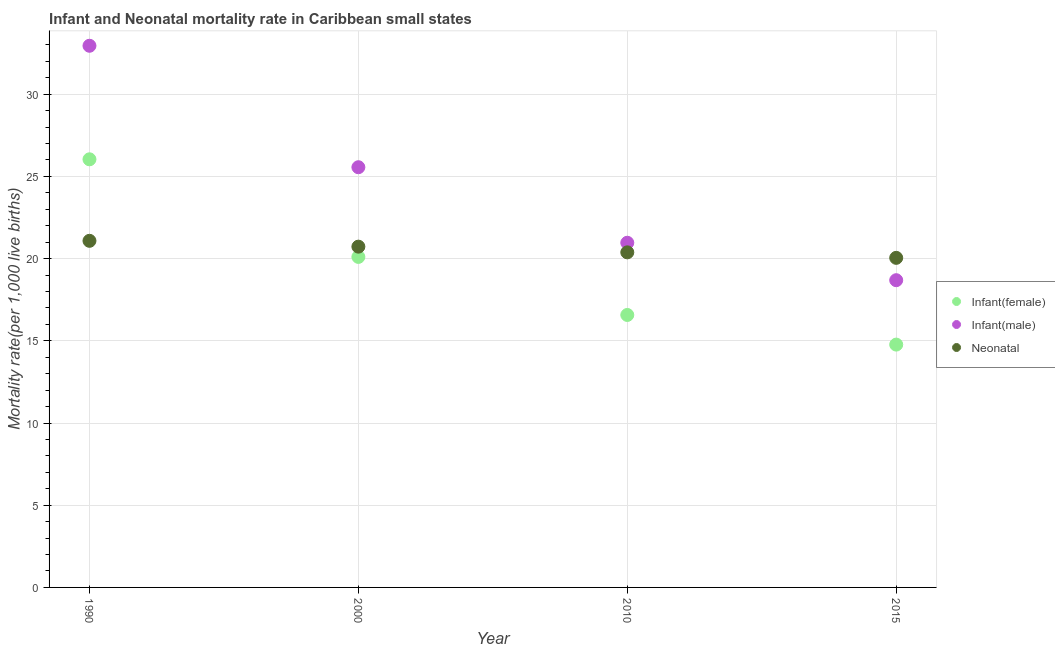How many different coloured dotlines are there?
Provide a short and direct response. 3. What is the neonatal mortality rate in 1990?
Offer a very short reply. 21.08. Across all years, what is the maximum infant mortality rate(female)?
Your answer should be compact. 26.04. Across all years, what is the minimum infant mortality rate(male)?
Give a very brief answer. 18.69. In which year was the infant mortality rate(male) minimum?
Offer a very short reply. 2015. What is the total infant mortality rate(male) in the graph?
Your answer should be very brief. 98.15. What is the difference between the infant mortality rate(female) in 2000 and that in 2015?
Ensure brevity in your answer.  5.33. What is the difference between the infant mortality rate(male) in 2000 and the neonatal mortality rate in 2015?
Make the answer very short. 5.51. What is the average infant mortality rate(male) per year?
Provide a short and direct response. 24.54. In the year 2000, what is the difference between the infant mortality rate(male) and infant mortality rate(female)?
Provide a short and direct response. 5.46. What is the ratio of the infant mortality rate(male) in 1990 to that in 2010?
Your answer should be very brief. 1.57. Is the difference between the infant mortality rate(female) in 2000 and 2015 greater than the difference between the infant mortality rate(male) in 2000 and 2015?
Make the answer very short. No. What is the difference between the highest and the second highest neonatal mortality rate?
Make the answer very short. 0.35. What is the difference between the highest and the lowest neonatal mortality rate?
Provide a short and direct response. 1.04. In how many years, is the infant mortality rate(male) greater than the average infant mortality rate(male) taken over all years?
Keep it short and to the point. 2. Is the sum of the neonatal mortality rate in 1990 and 2015 greater than the maximum infant mortality rate(male) across all years?
Provide a short and direct response. Yes. Is it the case that in every year, the sum of the infant mortality rate(female) and infant mortality rate(male) is greater than the neonatal mortality rate?
Provide a succinct answer. Yes. How many dotlines are there?
Make the answer very short. 3. Does the graph contain any zero values?
Provide a succinct answer. No. Where does the legend appear in the graph?
Offer a very short reply. Center right. How many legend labels are there?
Your answer should be compact. 3. What is the title of the graph?
Offer a very short reply. Infant and Neonatal mortality rate in Caribbean small states. Does "Taxes on international trade" appear as one of the legend labels in the graph?
Provide a succinct answer. No. What is the label or title of the Y-axis?
Provide a short and direct response. Mortality rate(per 1,0 live births). What is the Mortality rate(per 1,000 live births) in Infant(female) in 1990?
Keep it short and to the point. 26.04. What is the Mortality rate(per 1,000 live births) in Infant(male) in 1990?
Keep it short and to the point. 32.95. What is the Mortality rate(per 1,000 live births) of Neonatal  in 1990?
Your answer should be very brief. 21.08. What is the Mortality rate(per 1,000 live births) in Infant(female) in 2000?
Offer a very short reply. 20.1. What is the Mortality rate(per 1,000 live births) of Infant(male) in 2000?
Give a very brief answer. 25.56. What is the Mortality rate(per 1,000 live births) in Neonatal  in 2000?
Your answer should be compact. 20.73. What is the Mortality rate(per 1,000 live births) of Infant(female) in 2010?
Provide a succinct answer. 16.57. What is the Mortality rate(per 1,000 live births) in Infant(male) in 2010?
Give a very brief answer. 20.96. What is the Mortality rate(per 1,000 live births) in Neonatal  in 2010?
Ensure brevity in your answer.  20.38. What is the Mortality rate(per 1,000 live births) of Infant(female) in 2015?
Make the answer very short. 14.77. What is the Mortality rate(per 1,000 live births) in Infant(male) in 2015?
Provide a short and direct response. 18.69. What is the Mortality rate(per 1,000 live births) of Neonatal  in 2015?
Offer a terse response. 20.05. Across all years, what is the maximum Mortality rate(per 1,000 live births) of Infant(female)?
Keep it short and to the point. 26.04. Across all years, what is the maximum Mortality rate(per 1,000 live births) of Infant(male)?
Ensure brevity in your answer.  32.95. Across all years, what is the maximum Mortality rate(per 1,000 live births) in Neonatal ?
Your answer should be very brief. 21.08. Across all years, what is the minimum Mortality rate(per 1,000 live births) of Infant(female)?
Ensure brevity in your answer.  14.77. Across all years, what is the minimum Mortality rate(per 1,000 live births) in Infant(male)?
Give a very brief answer. 18.69. Across all years, what is the minimum Mortality rate(per 1,000 live births) in Neonatal ?
Give a very brief answer. 20.05. What is the total Mortality rate(per 1,000 live births) in Infant(female) in the graph?
Your response must be concise. 77.48. What is the total Mortality rate(per 1,000 live births) in Infant(male) in the graph?
Offer a very short reply. 98.15. What is the total Mortality rate(per 1,000 live births) in Neonatal  in the graph?
Provide a short and direct response. 82.23. What is the difference between the Mortality rate(per 1,000 live births) of Infant(female) in 1990 and that in 2000?
Your response must be concise. 5.94. What is the difference between the Mortality rate(per 1,000 live births) of Infant(male) in 1990 and that in 2000?
Provide a succinct answer. 7.39. What is the difference between the Mortality rate(per 1,000 live births) of Neonatal  in 1990 and that in 2000?
Your answer should be very brief. 0.35. What is the difference between the Mortality rate(per 1,000 live births) of Infant(female) in 1990 and that in 2010?
Make the answer very short. 9.47. What is the difference between the Mortality rate(per 1,000 live births) in Infant(male) in 1990 and that in 2010?
Your answer should be very brief. 11.98. What is the difference between the Mortality rate(per 1,000 live births) in Neonatal  in 1990 and that in 2010?
Offer a terse response. 0.7. What is the difference between the Mortality rate(per 1,000 live births) of Infant(female) in 1990 and that in 2015?
Provide a succinct answer. 11.27. What is the difference between the Mortality rate(per 1,000 live births) of Infant(male) in 1990 and that in 2015?
Ensure brevity in your answer.  14.26. What is the difference between the Mortality rate(per 1,000 live births) of Neonatal  in 1990 and that in 2015?
Your response must be concise. 1.04. What is the difference between the Mortality rate(per 1,000 live births) in Infant(female) in 2000 and that in 2010?
Ensure brevity in your answer.  3.53. What is the difference between the Mortality rate(per 1,000 live births) in Infant(male) in 2000 and that in 2010?
Give a very brief answer. 4.59. What is the difference between the Mortality rate(per 1,000 live births) of Neonatal  in 2000 and that in 2010?
Your answer should be very brief. 0.35. What is the difference between the Mortality rate(per 1,000 live births) in Infant(female) in 2000 and that in 2015?
Offer a terse response. 5.33. What is the difference between the Mortality rate(per 1,000 live births) of Infant(male) in 2000 and that in 2015?
Your answer should be very brief. 6.87. What is the difference between the Mortality rate(per 1,000 live births) in Neonatal  in 2000 and that in 2015?
Keep it short and to the point. 0.68. What is the difference between the Mortality rate(per 1,000 live births) in Infant(female) in 2010 and that in 2015?
Provide a succinct answer. 1.8. What is the difference between the Mortality rate(per 1,000 live births) in Infant(male) in 2010 and that in 2015?
Offer a very short reply. 2.28. What is the difference between the Mortality rate(per 1,000 live births) of Neonatal  in 2010 and that in 2015?
Ensure brevity in your answer.  0.33. What is the difference between the Mortality rate(per 1,000 live births) of Infant(female) in 1990 and the Mortality rate(per 1,000 live births) of Infant(male) in 2000?
Your answer should be very brief. 0.48. What is the difference between the Mortality rate(per 1,000 live births) of Infant(female) in 1990 and the Mortality rate(per 1,000 live births) of Neonatal  in 2000?
Your answer should be compact. 5.31. What is the difference between the Mortality rate(per 1,000 live births) in Infant(male) in 1990 and the Mortality rate(per 1,000 live births) in Neonatal  in 2000?
Your answer should be very brief. 12.22. What is the difference between the Mortality rate(per 1,000 live births) of Infant(female) in 1990 and the Mortality rate(per 1,000 live births) of Infant(male) in 2010?
Your answer should be compact. 5.08. What is the difference between the Mortality rate(per 1,000 live births) in Infant(female) in 1990 and the Mortality rate(per 1,000 live births) in Neonatal  in 2010?
Offer a terse response. 5.66. What is the difference between the Mortality rate(per 1,000 live births) of Infant(male) in 1990 and the Mortality rate(per 1,000 live births) of Neonatal  in 2010?
Offer a very short reply. 12.56. What is the difference between the Mortality rate(per 1,000 live births) of Infant(female) in 1990 and the Mortality rate(per 1,000 live births) of Infant(male) in 2015?
Give a very brief answer. 7.35. What is the difference between the Mortality rate(per 1,000 live births) in Infant(female) in 1990 and the Mortality rate(per 1,000 live births) in Neonatal  in 2015?
Make the answer very short. 5.99. What is the difference between the Mortality rate(per 1,000 live births) of Infant(male) in 1990 and the Mortality rate(per 1,000 live births) of Neonatal  in 2015?
Keep it short and to the point. 12.9. What is the difference between the Mortality rate(per 1,000 live births) of Infant(female) in 2000 and the Mortality rate(per 1,000 live births) of Infant(male) in 2010?
Make the answer very short. -0.86. What is the difference between the Mortality rate(per 1,000 live births) of Infant(female) in 2000 and the Mortality rate(per 1,000 live births) of Neonatal  in 2010?
Offer a very short reply. -0.28. What is the difference between the Mortality rate(per 1,000 live births) of Infant(male) in 2000 and the Mortality rate(per 1,000 live births) of Neonatal  in 2010?
Make the answer very short. 5.18. What is the difference between the Mortality rate(per 1,000 live births) of Infant(female) in 2000 and the Mortality rate(per 1,000 live births) of Infant(male) in 2015?
Provide a succinct answer. 1.42. What is the difference between the Mortality rate(per 1,000 live births) of Infant(female) in 2000 and the Mortality rate(per 1,000 live births) of Neonatal  in 2015?
Offer a very short reply. 0.06. What is the difference between the Mortality rate(per 1,000 live births) in Infant(male) in 2000 and the Mortality rate(per 1,000 live births) in Neonatal  in 2015?
Make the answer very short. 5.51. What is the difference between the Mortality rate(per 1,000 live births) of Infant(female) in 2010 and the Mortality rate(per 1,000 live births) of Infant(male) in 2015?
Your response must be concise. -2.11. What is the difference between the Mortality rate(per 1,000 live births) in Infant(female) in 2010 and the Mortality rate(per 1,000 live births) in Neonatal  in 2015?
Make the answer very short. -3.47. What is the difference between the Mortality rate(per 1,000 live births) of Infant(male) in 2010 and the Mortality rate(per 1,000 live births) of Neonatal  in 2015?
Your answer should be compact. 0.92. What is the average Mortality rate(per 1,000 live births) in Infant(female) per year?
Offer a terse response. 19.37. What is the average Mortality rate(per 1,000 live births) of Infant(male) per year?
Provide a succinct answer. 24.54. What is the average Mortality rate(per 1,000 live births) in Neonatal  per year?
Make the answer very short. 20.56. In the year 1990, what is the difference between the Mortality rate(per 1,000 live births) in Infant(female) and Mortality rate(per 1,000 live births) in Infant(male)?
Your answer should be compact. -6.91. In the year 1990, what is the difference between the Mortality rate(per 1,000 live births) of Infant(female) and Mortality rate(per 1,000 live births) of Neonatal ?
Give a very brief answer. 4.96. In the year 1990, what is the difference between the Mortality rate(per 1,000 live births) in Infant(male) and Mortality rate(per 1,000 live births) in Neonatal ?
Give a very brief answer. 11.86. In the year 2000, what is the difference between the Mortality rate(per 1,000 live births) in Infant(female) and Mortality rate(per 1,000 live births) in Infant(male)?
Make the answer very short. -5.46. In the year 2000, what is the difference between the Mortality rate(per 1,000 live births) in Infant(female) and Mortality rate(per 1,000 live births) in Neonatal ?
Keep it short and to the point. -0.62. In the year 2000, what is the difference between the Mortality rate(per 1,000 live births) of Infant(male) and Mortality rate(per 1,000 live births) of Neonatal ?
Provide a succinct answer. 4.83. In the year 2010, what is the difference between the Mortality rate(per 1,000 live births) in Infant(female) and Mortality rate(per 1,000 live births) in Infant(male)?
Offer a very short reply. -4.39. In the year 2010, what is the difference between the Mortality rate(per 1,000 live births) of Infant(female) and Mortality rate(per 1,000 live births) of Neonatal ?
Provide a short and direct response. -3.81. In the year 2010, what is the difference between the Mortality rate(per 1,000 live births) in Infant(male) and Mortality rate(per 1,000 live births) in Neonatal ?
Keep it short and to the point. 0.58. In the year 2015, what is the difference between the Mortality rate(per 1,000 live births) of Infant(female) and Mortality rate(per 1,000 live births) of Infant(male)?
Your answer should be very brief. -3.92. In the year 2015, what is the difference between the Mortality rate(per 1,000 live births) in Infant(female) and Mortality rate(per 1,000 live births) in Neonatal ?
Your answer should be very brief. -5.28. In the year 2015, what is the difference between the Mortality rate(per 1,000 live births) in Infant(male) and Mortality rate(per 1,000 live births) in Neonatal ?
Provide a succinct answer. -1.36. What is the ratio of the Mortality rate(per 1,000 live births) of Infant(female) in 1990 to that in 2000?
Your answer should be very brief. 1.3. What is the ratio of the Mortality rate(per 1,000 live births) of Infant(male) in 1990 to that in 2000?
Offer a very short reply. 1.29. What is the ratio of the Mortality rate(per 1,000 live births) of Neonatal  in 1990 to that in 2000?
Your response must be concise. 1.02. What is the ratio of the Mortality rate(per 1,000 live births) in Infant(female) in 1990 to that in 2010?
Ensure brevity in your answer.  1.57. What is the ratio of the Mortality rate(per 1,000 live births) in Infant(male) in 1990 to that in 2010?
Keep it short and to the point. 1.57. What is the ratio of the Mortality rate(per 1,000 live births) in Neonatal  in 1990 to that in 2010?
Provide a succinct answer. 1.03. What is the ratio of the Mortality rate(per 1,000 live births) in Infant(female) in 1990 to that in 2015?
Give a very brief answer. 1.76. What is the ratio of the Mortality rate(per 1,000 live births) in Infant(male) in 1990 to that in 2015?
Ensure brevity in your answer.  1.76. What is the ratio of the Mortality rate(per 1,000 live births) in Neonatal  in 1990 to that in 2015?
Give a very brief answer. 1.05. What is the ratio of the Mortality rate(per 1,000 live births) of Infant(female) in 2000 to that in 2010?
Provide a short and direct response. 1.21. What is the ratio of the Mortality rate(per 1,000 live births) of Infant(male) in 2000 to that in 2010?
Provide a succinct answer. 1.22. What is the ratio of the Mortality rate(per 1,000 live births) of Neonatal  in 2000 to that in 2010?
Offer a terse response. 1.02. What is the ratio of the Mortality rate(per 1,000 live births) in Infant(female) in 2000 to that in 2015?
Make the answer very short. 1.36. What is the ratio of the Mortality rate(per 1,000 live births) of Infant(male) in 2000 to that in 2015?
Offer a very short reply. 1.37. What is the ratio of the Mortality rate(per 1,000 live births) of Neonatal  in 2000 to that in 2015?
Your response must be concise. 1.03. What is the ratio of the Mortality rate(per 1,000 live births) in Infant(female) in 2010 to that in 2015?
Make the answer very short. 1.12. What is the ratio of the Mortality rate(per 1,000 live births) in Infant(male) in 2010 to that in 2015?
Offer a very short reply. 1.12. What is the ratio of the Mortality rate(per 1,000 live births) of Neonatal  in 2010 to that in 2015?
Your answer should be very brief. 1.02. What is the difference between the highest and the second highest Mortality rate(per 1,000 live births) in Infant(female)?
Your answer should be very brief. 5.94. What is the difference between the highest and the second highest Mortality rate(per 1,000 live births) of Infant(male)?
Your answer should be compact. 7.39. What is the difference between the highest and the second highest Mortality rate(per 1,000 live births) in Neonatal ?
Ensure brevity in your answer.  0.35. What is the difference between the highest and the lowest Mortality rate(per 1,000 live births) in Infant(female)?
Your answer should be very brief. 11.27. What is the difference between the highest and the lowest Mortality rate(per 1,000 live births) of Infant(male)?
Give a very brief answer. 14.26. What is the difference between the highest and the lowest Mortality rate(per 1,000 live births) in Neonatal ?
Keep it short and to the point. 1.04. 